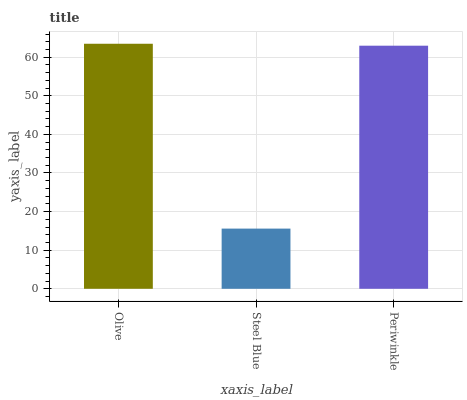Is Steel Blue the minimum?
Answer yes or no. Yes. Is Olive the maximum?
Answer yes or no. Yes. Is Periwinkle the minimum?
Answer yes or no. No. Is Periwinkle the maximum?
Answer yes or no. No. Is Periwinkle greater than Steel Blue?
Answer yes or no. Yes. Is Steel Blue less than Periwinkle?
Answer yes or no. Yes. Is Steel Blue greater than Periwinkle?
Answer yes or no. No. Is Periwinkle less than Steel Blue?
Answer yes or no. No. Is Periwinkle the high median?
Answer yes or no. Yes. Is Periwinkle the low median?
Answer yes or no. Yes. Is Olive the high median?
Answer yes or no. No. Is Olive the low median?
Answer yes or no. No. 